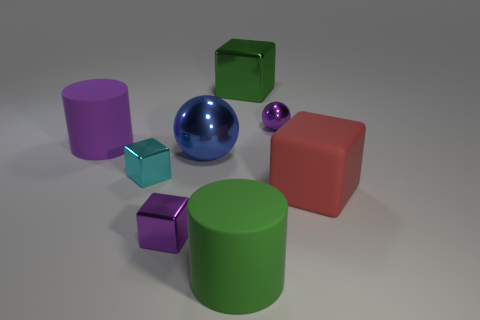Subtract all green metal blocks. How many blocks are left? 3 Add 1 large things. How many objects exist? 9 Subtract all cylinders. How many objects are left? 6 Subtract all green cylinders. How many cylinders are left? 1 Subtract all tiny blocks. Subtract all blocks. How many objects are left? 2 Add 6 blue balls. How many blue balls are left? 7 Add 7 large blue metallic spheres. How many large blue metallic spheres exist? 8 Subtract 0 red spheres. How many objects are left? 8 Subtract all blue blocks. Subtract all cyan spheres. How many blocks are left? 4 